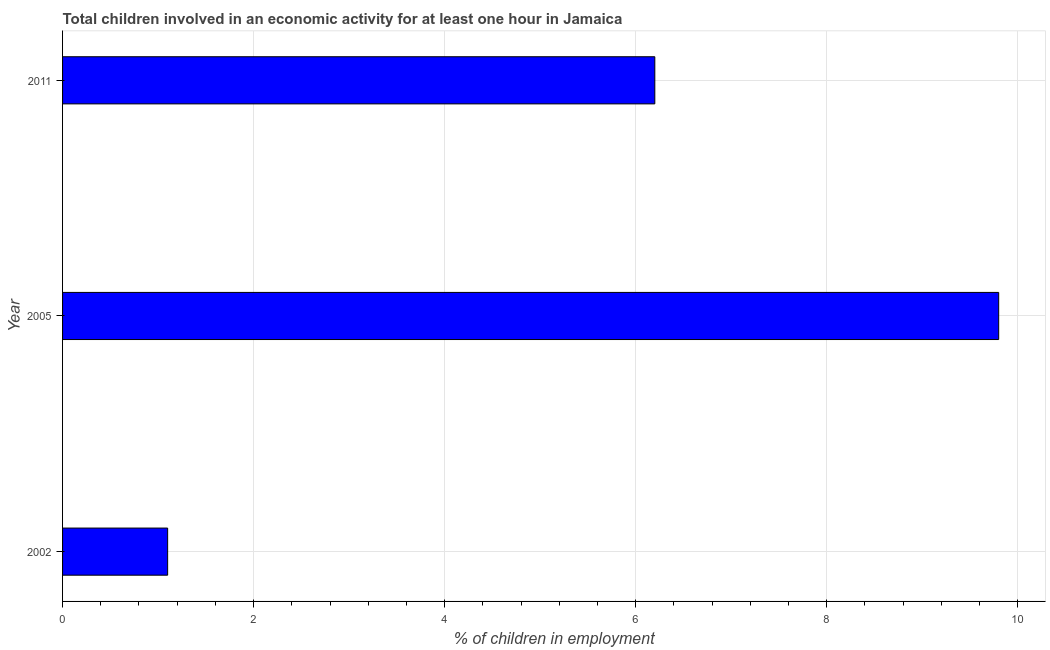Does the graph contain any zero values?
Give a very brief answer. No. Does the graph contain grids?
Your answer should be very brief. Yes. What is the title of the graph?
Your response must be concise. Total children involved in an economic activity for at least one hour in Jamaica. What is the label or title of the X-axis?
Ensure brevity in your answer.  % of children in employment. What is the label or title of the Y-axis?
Offer a very short reply. Year. What is the percentage of children in employment in 2005?
Your answer should be compact. 9.8. In which year was the percentage of children in employment maximum?
Offer a terse response. 2005. What is the sum of the percentage of children in employment?
Give a very brief answer. 17.1. What is the average percentage of children in employment per year?
Keep it short and to the point. 5.7. In how many years, is the percentage of children in employment greater than 3.2 %?
Your answer should be very brief. 2. Do a majority of the years between 2002 and 2005 (inclusive) have percentage of children in employment greater than 4.4 %?
Make the answer very short. No. What is the ratio of the percentage of children in employment in 2005 to that in 2011?
Offer a very short reply. 1.58. Is the difference between the percentage of children in employment in 2002 and 2005 greater than the difference between any two years?
Provide a succinct answer. Yes. What is the difference between the highest and the second highest percentage of children in employment?
Provide a succinct answer. 3.6. Is the sum of the percentage of children in employment in 2005 and 2011 greater than the maximum percentage of children in employment across all years?
Give a very brief answer. Yes. Are all the bars in the graph horizontal?
Your answer should be very brief. Yes. How many years are there in the graph?
Keep it short and to the point. 3. Are the values on the major ticks of X-axis written in scientific E-notation?
Offer a very short reply. No. What is the % of children in employment in 2002?
Keep it short and to the point. 1.1. What is the difference between the % of children in employment in 2002 and 2005?
Your answer should be very brief. -8.7. What is the difference between the % of children in employment in 2002 and 2011?
Your answer should be very brief. -5.1. What is the ratio of the % of children in employment in 2002 to that in 2005?
Give a very brief answer. 0.11. What is the ratio of the % of children in employment in 2002 to that in 2011?
Keep it short and to the point. 0.18. What is the ratio of the % of children in employment in 2005 to that in 2011?
Give a very brief answer. 1.58. 